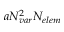<formula> <loc_0><loc_0><loc_500><loc_500>a { N _ { v a r } } ^ { 2 } { N _ { e l e m } }</formula> 